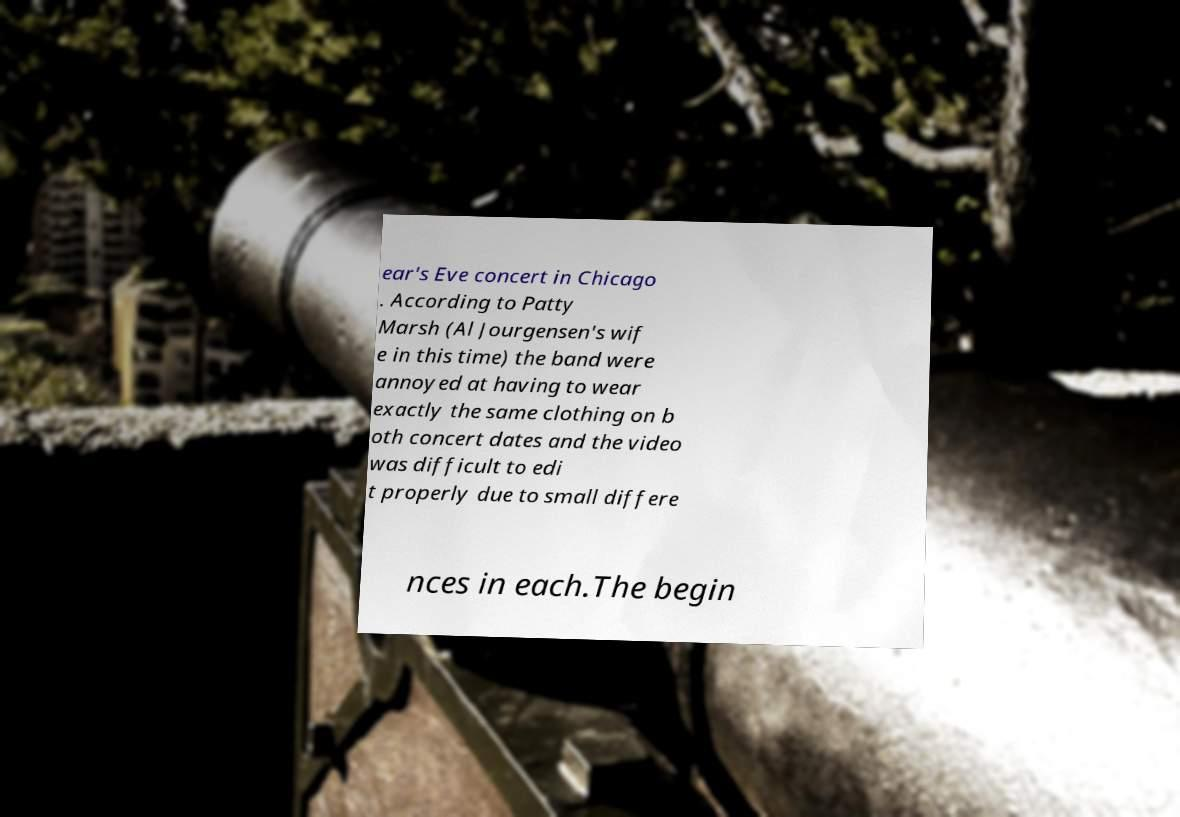Please identify and transcribe the text found in this image. ear's Eve concert in Chicago . According to Patty Marsh (Al Jourgensen's wif e in this time) the band were annoyed at having to wear exactly the same clothing on b oth concert dates and the video was difficult to edi t properly due to small differe nces in each.The begin 